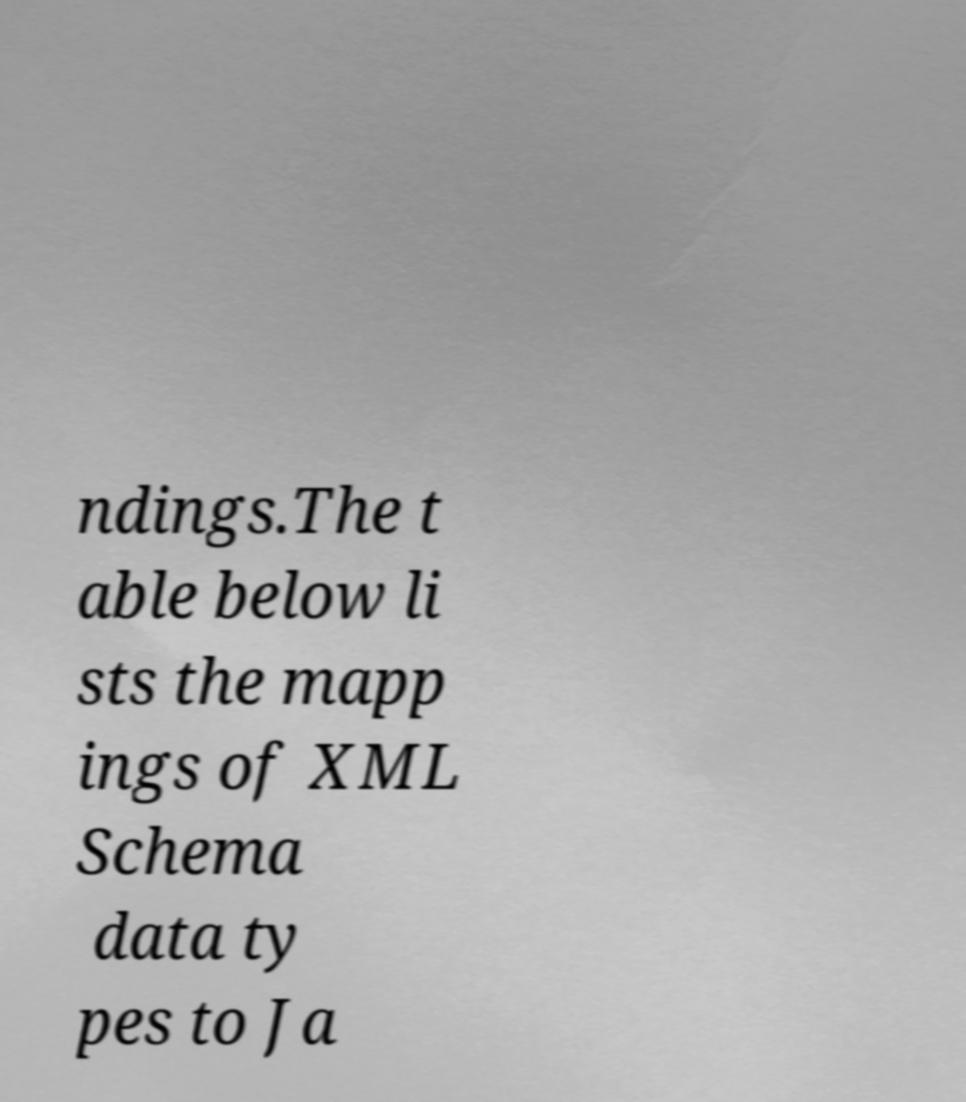Can you read and provide the text displayed in the image?This photo seems to have some interesting text. Can you extract and type it out for me? ndings.The t able below li sts the mapp ings of XML Schema data ty pes to Ja 